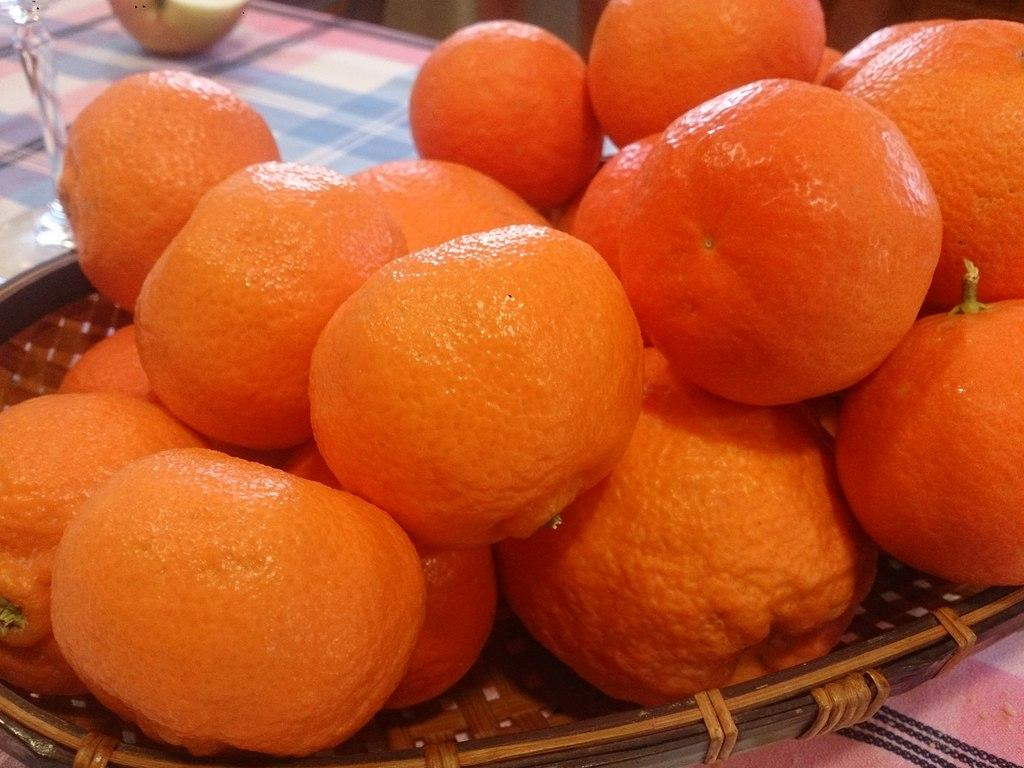What is inside the basket that is visible in the image? There is a basket with oranges in the image. What is the basket placed on? The basket is on a cloth. Can you describe the background of the image? There is an object and a fruit in the background of the image. What type of question can be seen written on the fruit in the background? There is no question written on the fruit in the background; it is a fruit and not a surface for writing. 